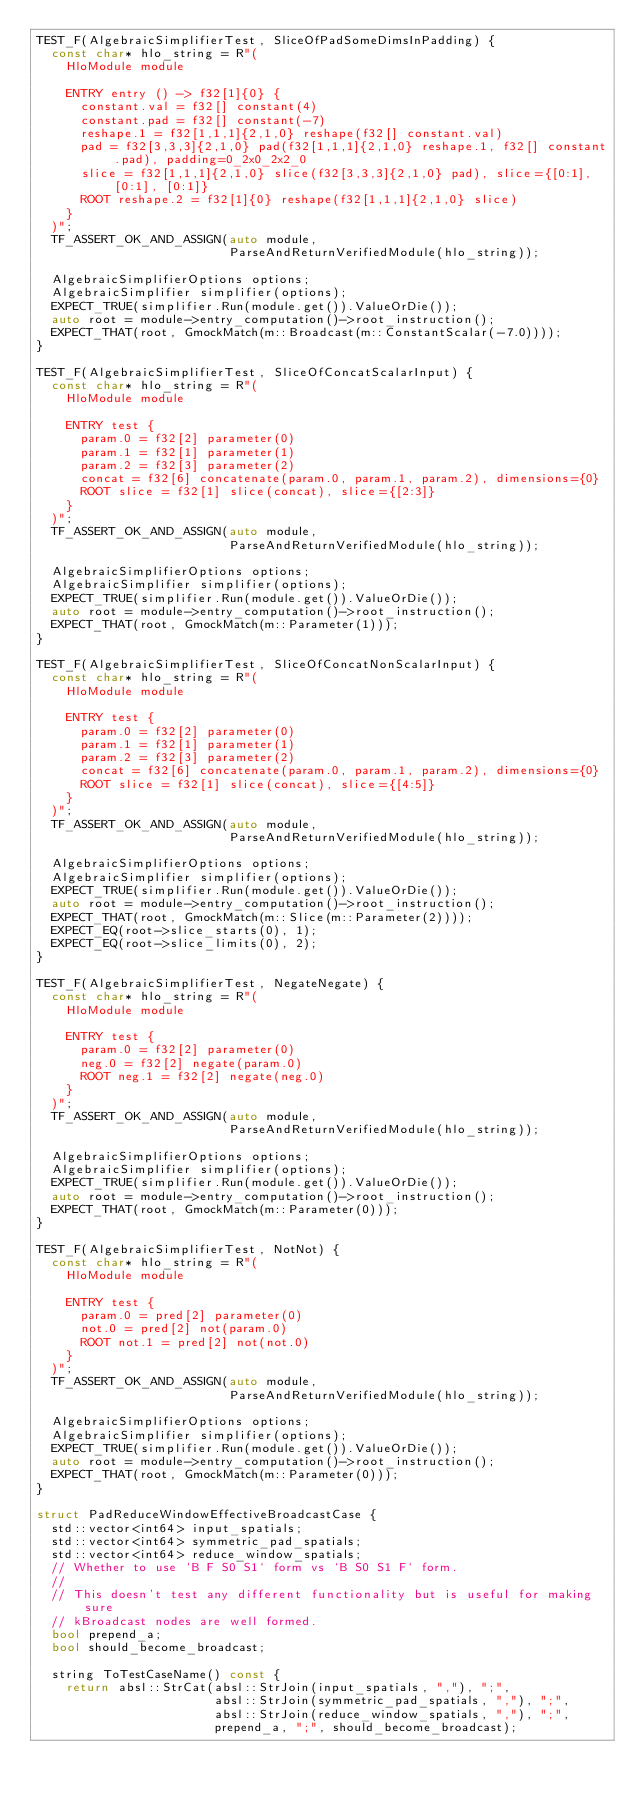<code> <loc_0><loc_0><loc_500><loc_500><_C++_>TEST_F(AlgebraicSimplifierTest, SliceOfPadSomeDimsInPadding) {
  const char* hlo_string = R"(
    HloModule module

    ENTRY entry () -> f32[1]{0} {
      constant.val = f32[] constant(4)
      constant.pad = f32[] constant(-7)
      reshape.1 = f32[1,1,1]{2,1,0} reshape(f32[] constant.val)
      pad = f32[3,3,3]{2,1,0} pad(f32[1,1,1]{2,1,0} reshape.1, f32[] constant.pad), padding=0_2x0_2x2_0
      slice = f32[1,1,1]{2,1,0} slice(f32[3,3,3]{2,1,0} pad), slice={[0:1], [0:1], [0:1]}
      ROOT reshape.2 = f32[1]{0} reshape(f32[1,1,1]{2,1,0} slice)
    }
  )";
  TF_ASSERT_OK_AND_ASSIGN(auto module,
                          ParseAndReturnVerifiedModule(hlo_string));

  AlgebraicSimplifierOptions options;
  AlgebraicSimplifier simplifier(options);
  EXPECT_TRUE(simplifier.Run(module.get()).ValueOrDie());
  auto root = module->entry_computation()->root_instruction();
  EXPECT_THAT(root, GmockMatch(m::Broadcast(m::ConstantScalar(-7.0))));
}

TEST_F(AlgebraicSimplifierTest, SliceOfConcatScalarInput) {
  const char* hlo_string = R"(
    HloModule module

    ENTRY test {
      param.0 = f32[2] parameter(0)
      param.1 = f32[1] parameter(1)
      param.2 = f32[3] parameter(2)
      concat = f32[6] concatenate(param.0, param.1, param.2), dimensions={0}
      ROOT slice = f32[1] slice(concat), slice={[2:3]}
    }
  )";
  TF_ASSERT_OK_AND_ASSIGN(auto module,
                          ParseAndReturnVerifiedModule(hlo_string));

  AlgebraicSimplifierOptions options;
  AlgebraicSimplifier simplifier(options);
  EXPECT_TRUE(simplifier.Run(module.get()).ValueOrDie());
  auto root = module->entry_computation()->root_instruction();
  EXPECT_THAT(root, GmockMatch(m::Parameter(1)));
}

TEST_F(AlgebraicSimplifierTest, SliceOfConcatNonScalarInput) {
  const char* hlo_string = R"(
    HloModule module

    ENTRY test {
      param.0 = f32[2] parameter(0)
      param.1 = f32[1] parameter(1)
      param.2 = f32[3] parameter(2)
      concat = f32[6] concatenate(param.0, param.1, param.2), dimensions={0}
      ROOT slice = f32[1] slice(concat), slice={[4:5]}
    }
  )";
  TF_ASSERT_OK_AND_ASSIGN(auto module,
                          ParseAndReturnVerifiedModule(hlo_string));

  AlgebraicSimplifierOptions options;
  AlgebraicSimplifier simplifier(options);
  EXPECT_TRUE(simplifier.Run(module.get()).ValueOrDie());
  auto root = module->entry_computation()->root_instruction();
  EXPECT_THAT(root, GmockMatch(m::Slice(m::Parameter(2))));
  EXPECT_EQ(root->slice_starts(0), 1);
  EXPECT_EQ(root->slice_limits(0), 2);
}

TEST_F(AlgebraicSimplifierTest, NegateNegate) {
  const char* hlo_string = R"(
    HloModule module

    ENTRY test {
      param.0 = f32[2] parameter(0)
      neg.0 = f32[2] negate(param.0)
      ROOT neg.1 = f32[2] negate(neg.0)
    }
  )";
  TF_ASSERT_OK_AND_ASSIGN(auto module,
                          ParseAndReturnVerifiedModule(hlo_string));

  AlgebraicSimplifierOptions options;
  AlgebraicSimplifier simplifier(options);
  EXPECT_TRUE(simplifier.Run(module.get()).ValueOrDie());
  auto root = module->entry_computation()->root_instruction();
  EXPECT_THAT(root, GmockMatch(m::Parameter(0)));
}

TEST_F(AlgebraicSimplifierTest, NotNot) {
  const char* hlo_string = R"(
    HloModule module

    ENTRY test {
      param.0 = pred[2] parameter(0)
      not.0 = pred[2] not(param.0)
      ROOT not.1 = pred[2] not(not.0)
    }
  )";
  TF_ASSERT_OK_AND_ASSIGN(auto module,
                          ParseAndReturnVerifiedModule(hlo_string));

  AlgebraicSimplifierOptions options;
  AlgebraicSimplifier simplifier(options);
  EXPECT_TRUE(simplifier.Run(module.get()).ValueOrDie());
  auto root = module->entry_computation()->root_instruction();
  EXPECT_THAT(root, GmockMatch(m::Parameter(0)));
}

struct PadReduceWindowEffectiveBroadcastCase {
  std::vector<int64> input_spatials;
  std::vector<int64> symmetric_pad_spatials;
  std::vector<int64> reduce_window_spatials;
  // Whether to use `B F S0 S1` form vs `B S0 S1 F` form.
  //
  // This doesn't test any different functionality but is useful for making sure
  // kBroadcast nodes are well formed.
  bool prepend_a;
  bool should_become_broadcast;

  string ToTestCaseName() const {
    return absl::StrCat(absl::StrJoin(input_spatials, ","), ";",
                        absl::StrJoin(symmetric_pad_spatials, ","), ";",
                        absl::StrJoin(reduce_window_spatials, ","), ";",
                        prepend_a, ";", should_become_broadcast);</code> 